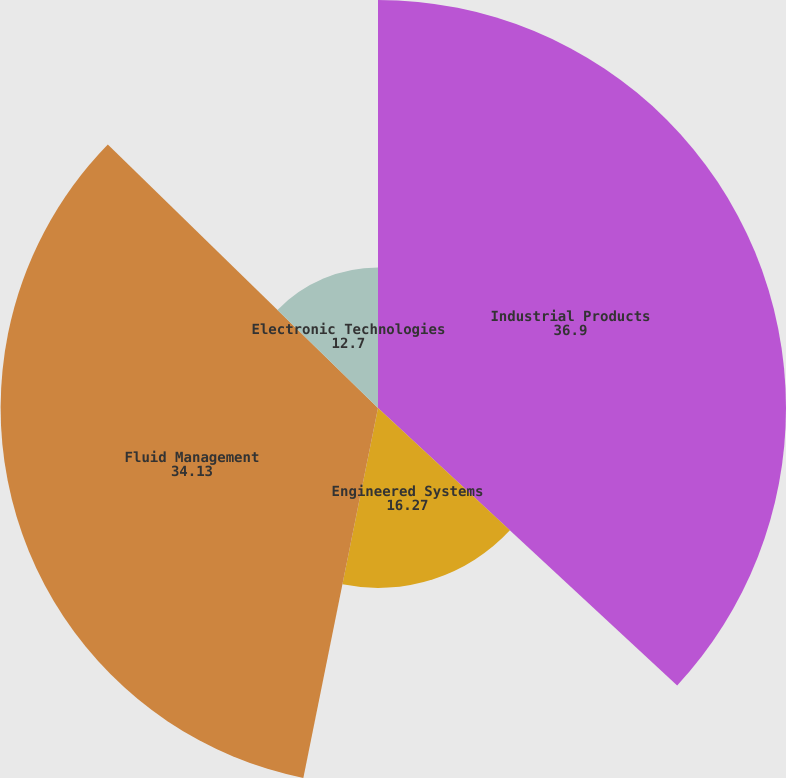<chart> <loc_0><loc_0><loc_500><loc_500><pie_chart><fcel>Industrial Products<fcel>Engineered Systems<fcel>Fluid Management<fcel>Electronic Technologies<nl><fcel>36.9%<fcel>16.27%<fcel>34.13%<fcel>12.7%<nl></chart> 